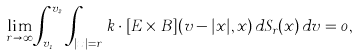<formula> <loc_0><loc_0><loc_500><loc_500>\lim _ { r \to \infty } \int _ { v _ { 1 } } ^ { v _ { 2 } } \int _ { | x | = r } k \cdot [ E \times B ] ( v - | x | , x ) \, d S _ { r } ( x ) \, d v = 0 ,</formula> 